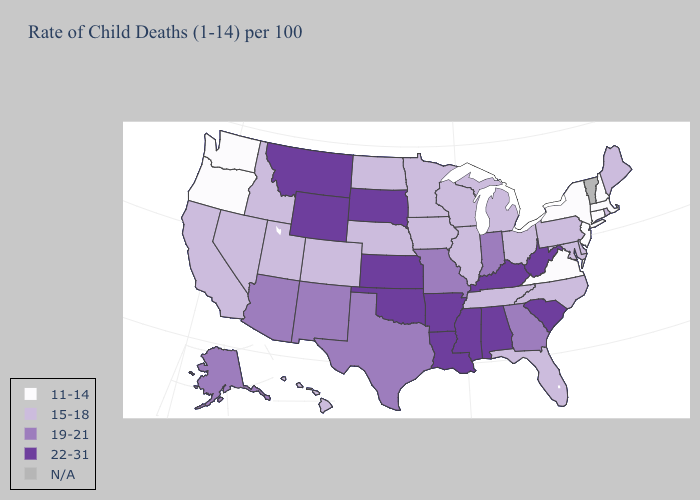Name the states that have a value in the range N/A?
Be succinct. Vermont. Name the states that have a value in the range 19-21?
Give a very brief answer. Alaska, Arizona, Georgia, Indiana, Missouri, New Mexico, Texas. Which states have the lowest value in the USA?
Be succinct. Connecticut, Massachusetts, New Hampshire, New Jersey, New York, Oregon, Virginia, Washington. Does West Virginia have the highest value in the USA?
Give a very brief answer. Yes. Does Illinois have the highest value in the USA?
Give a very brief answer. No. Name the states that have a value in the range 15-18?
Write a very short answer. California, Colorado, Delaware, Florida, Hawaii, Idaho, Illinois, Iowa, Maine, Maryland, Michigan, Minnesota, Nebraska, Nevada, North Carolina, North Dakota, Ohio, Pennsylvania, Rhode Island, Tennessee, Utah, Wisconsin. Which states have the lowest value in the USA?
Give a very brief answer. Connecticut, Massachusetts, New Hampshire, New Jersey, New York, Oregon, Virginia, Washington. Does the first symbol in the legend represent the smallest category?
Be succinct. Yes. What is the value of Michigan?
Short answer required. 15-18. What is the highest value in the USA?
Give a very brief answer. 22-31. Does Kansas have the lowest value in the MidWest?
Concise answer only. No. Which states have the lowest value in the USA?
Short answer required. Connecticut, Massachusetts, New Hampshire, New Jersey, New York, Oregon, Virginia, Washington. What is the lowest value in the South?
Give a very brief answer. 11-14. 